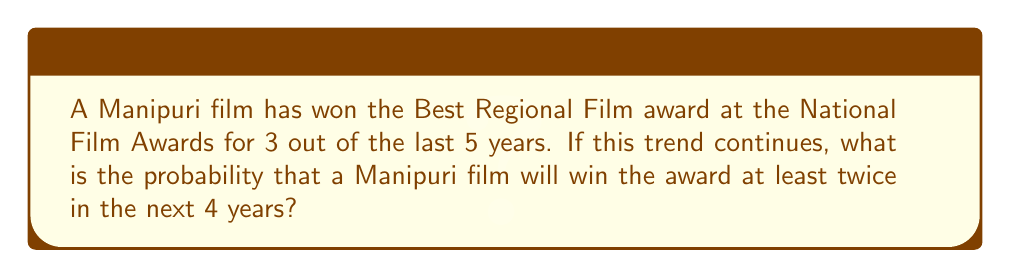Can you answer this question? Let's approach this step-by-step:

1) First, we need to calculate the probability of a Manipuri film winning in any given year:
   $p = \frac{3}{5} = 0.6$

2) The probability of not winning in a given year is:
   $q = 1 - p = 1 - 0.6 = 0.4$

3) We want the probability of winning at least twice in 4 years. It's easier to calculate the probability of winning 0 or 1 time and subtract from 1.

4) Let's use the binomial probability formula:
   $P(X = k) = \binom{n}{k} p^k q^{n-k}$

   Where $n = 4$ (years), $p = 0.6$, $q = 0.4$

5) Probability of winning 0 times:
   $P(X = 0) = \binom{4}{0} (0.6)^0 (0.4)^4 = 1 \cdot 1 \cdot 0.0256 = 0.0256$

6) Probability of winning 1 time:
   $P(X = 1) = \binom{4}{1} (0.6)^1 (0.4)^3 = 4 \cdot 0.6 \cdot 0.064 = 0.1536$

7) Probability of winning 0 or 1 time:
   $P(X \leq 1) = 0.0256 + 0.1536 = 0.1792$

8) Therefore, the probability of winning at least twice is:
   $P(X \geq 2) = 1 - P(X \leq 1) = 1 - 0.1792 = 0.8208$
Answer: $0.8208$ or $82.08\%$ 